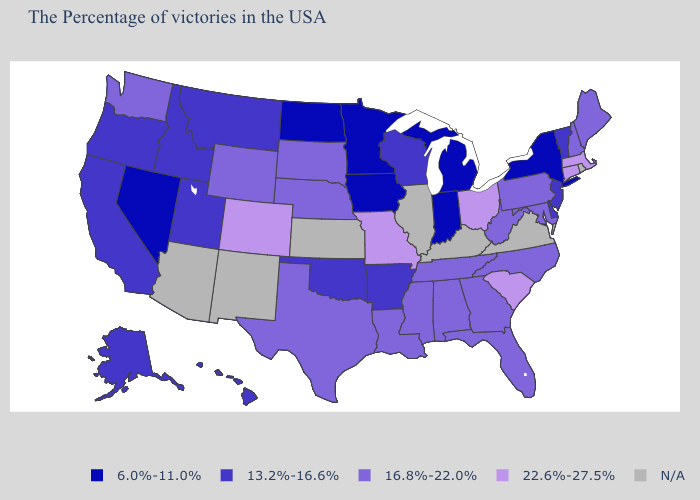Among the states that border Missouri , which have the highest value?
Short answer required. Tennessee, Nebraska. Name the states that have a value in the range 22.6%-27.5%?
Answer briefly. Massachusetts, Connecticut, South Carolina, Ohio, Missouri, Colorado. Which states have the lowest value in the West?
Answer briefly. Nevada. Name the states that have a value in the range 13.2%-16.6%?
Short answer required. Vermont, New Jersey, Delaware, Wisconsin, Arkansas, Oklahoma, Utah, Montana, Idaho, California, Oregon, Alaska, Hawaii. What is the value of Kentucky?
Give a very brief answer. N/A. Name the states that have a value in the range 6.0%-11.0%?
Quick response, please. New York, Michigan, Indiana, Minnesota, Iowa, North Dakota, Nevada. Which states have the lowest value in the USA?
Be succinct. New York, Michigan, Indiana, Minnesota, Iowa, North Dakota, Nevada. What is the highest value in the Northeast ?
Answer briefly. 22.6%-27.5%. Among the states that border New Jersey , which have the highest value?
Quick response, please. Pennsylvania. Name the states that have a value in the range 13.2%-16.6%?
Concise answer only. Vermont, New Jersey, Delaware, Wisconsin, Arkansas, Oklahoma, Utah, Montana, Idaho, California, Oregon, Alaska, Hawaii. What is the value of Illinois?
Give a very brief answer. N/A. What is the value of Montana?
Short answer required. 13.2%-16.6%. Which states hav the highest value in the Northeast?
Be succinct. Massachusetts, Connecticut. 